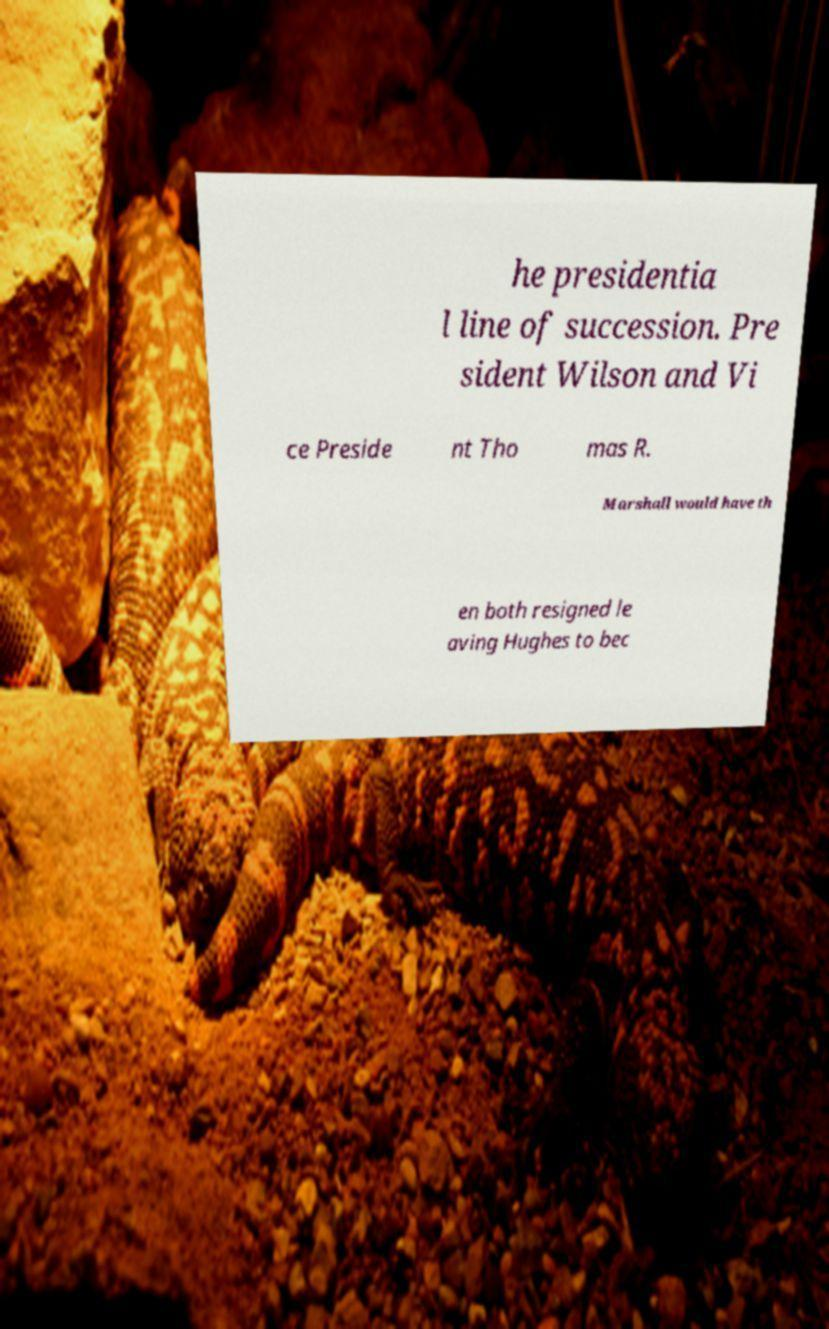Please read and relay the text visible in this image. What does it say? he presidentia l line of succession. Pre sident Wilson and Vi ce Preside nt Tho mas R. Marshall would have th en both resigned le aving Hughes to bec 